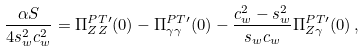Convert formula to latex. <formula><loc_0><loc_0><loc_500><loc_500>\frac { \alpha S } { 4 s _ { w } ^ { 2 } c _ { w } ^ { 2 } } = \Pi _ { Z Z } ^ { P T \prime } ( 0 ) - \Pi _ { \gamma \gamma } ^ { P T \prime } ( 0 ) - \frac { c _ { w } ^ { 2 } - s _ { w } ^ { 2 } } { s _ { w } c _ { w } } \Pi _ { Z \gamma } ^ { P T \prime } ( 0 ) \, ,</formula> 